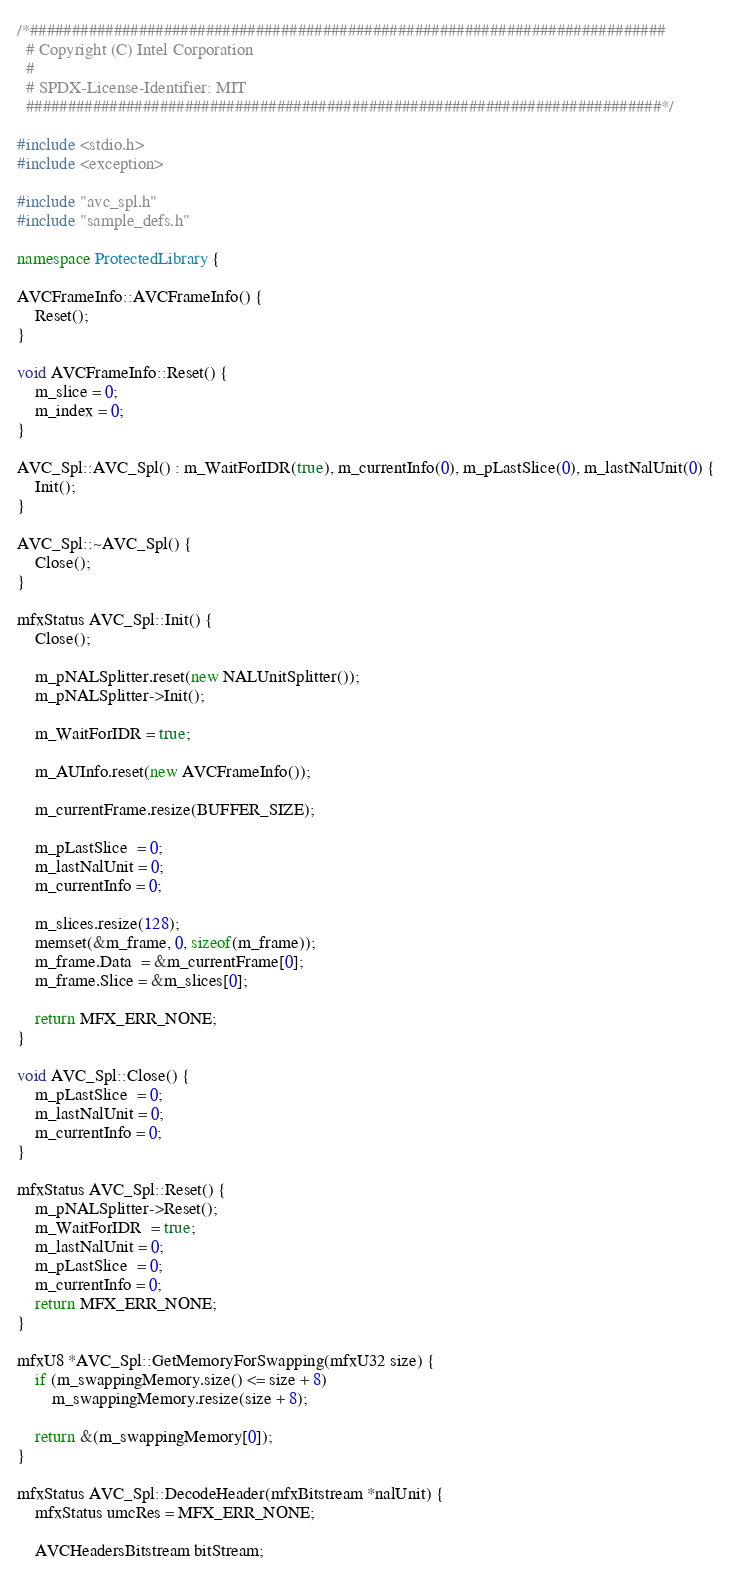<code> <loc_0><loc_0><loc_500><loc_500><_C++_>/*############################################################################
  # Copyright (C) Intel Corporation
  #
  # SPDX-License-Identifier: MIT
  ############################################################################*/

#include <stdio.h>
#include <exception>

#include "avc_spl.h"
#include "sample_defs.h"

namespace ProtectedLibrary {

AVCFrameInfo::AVCFrameInfo() {
    Reset();
}

void AVCFrameInfo::Reset() {
    m_slice = 0;
    m_index = 0;
}

AVC_Spl::AVC_Spl() : m_WaitForIDR(true), m_currentInfo(0), m_pLastSlice(0), m_lastNalUnit(0) {
    Init();
}

AVC_Spl::~AVC_Spl() {
    Close();
}

mfxStatus AVC_Spl::Init() {
    Close();

    m_pNALSplitter.reset(new NALUnitSplitter());
    m_pNALSplitter->Init();

    m_WaitForIDR = true;

    m_AUInfo.reset(new AVCFrameInfo());

    m_currentFrame.resize(BUFFER_SIZE);

    m_pLastSlice  = 0;
    m_lastNalUnit = 0;
    m_currentInfo = 0;

    m_slices.resize(128);
    memset(&m_frame, 0, sizeof(m_frame));
    m_frame.Data  = &m_currentFrame[0];
    m_frame.Slice = &m_slices[0];

    return MFX_ERR_NONE;
}

void AVC_Spl::Close() {
    m_pLastSlice  = 0;
    m_lastNalUnit = 0;
    m_currentInfo = 0;
}

mfxStatus AVC_Spl::Reset() {
    m_pNALSplitter->Reset();
    m_WaitForIDR  = true;
    m_lastNalUnit = 0;
    m_pLastSlice  = 0;
    m_currentInfo = 0;
    return MFX_ERR_NONE;
}

mfxU8 *AVC_Spl::GetMemoryForSwapping(mfxU32 size) {
    if (m_swappingMemory.size() <= size + 8)
        m_swappingMemory.resize(size + 8);

    return &(m_swappingMemory[0]);
}

mfxStatus AVC_Spl::DecodeHeader(mfxBitstream *nalUnit) {
    mfxStatus umcRes = MFX_ERR_NONE;

    AVCHeadersBitstream bitStream;
</code> 